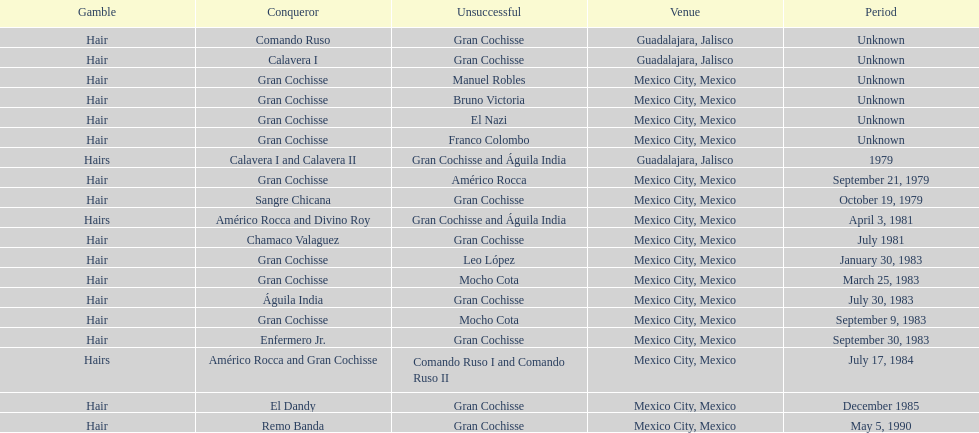How many winners were there before bruno victoria lost? 3. 